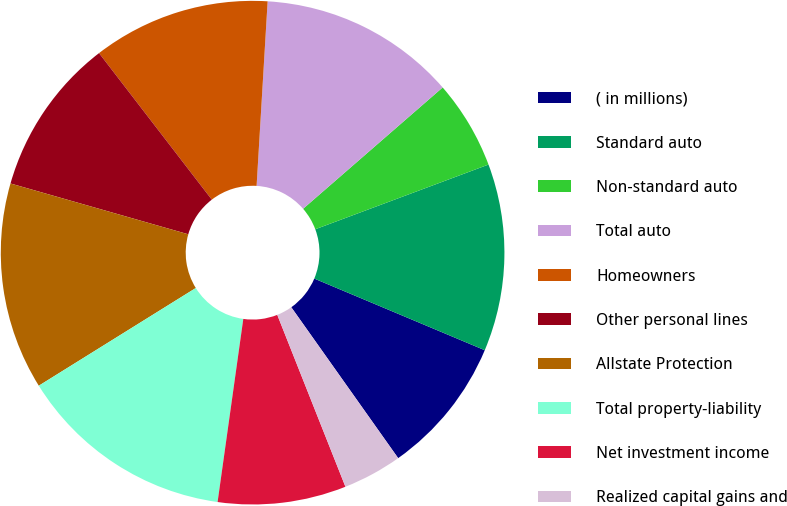Convert chart to OTSL. <chart><loc_0><loc_0><loc_500><loc_500><pie_chart><fcel>( in millions)<fcel>Standard auto<fcel>Non-standard auto<fcel>Total auto<fcel>Homeowners<fcel>Other personal lines<fcel>Allstate Protection<fcel>Total property-liability<fcel>Net investment income<fcel>Realized capital gains and<nl><fcel>8.86%<fcel>12.02%<fcel>5.7%<fcel>12.66%<fcel>11.39%<fcel>10.13%<fcel>13.29%<fcel>13.92%<fcel>8.23%<fcel>3.8%<nl></chart> 